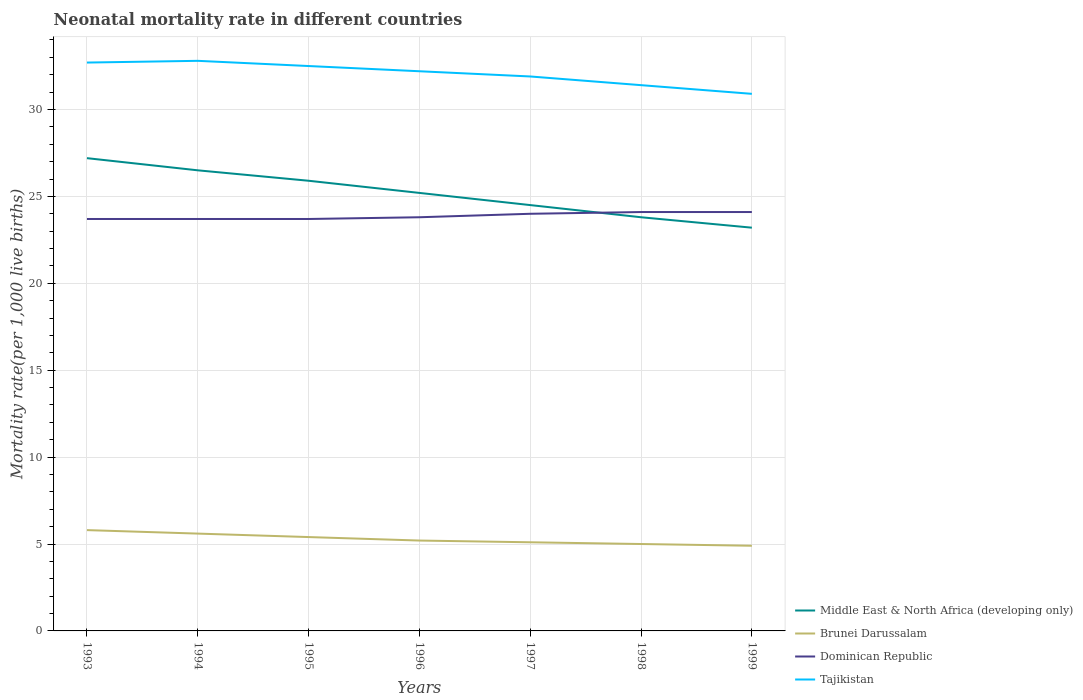Does the line corresponding to Brunei Darussalam intersect with the line corresponding to Dominican Republic?
Provide a succinct answer. No. Is the number of lines equal to the number of legend labels?
Make the answer very short. Yes. Across all years, what is the maximum neonatal mortality rate in Brunei Darussalam?
Offer a terse response. 4.9. In which year was the neonatal mortality rate in Middle East & North Africa (developing only) maximum?
Provide a succinct answer. 1999. What is the total neonatal mortality rate in Brunei Darussalam in the graph?
Offer a very short reply. 0.8. What is the difference between two consecutive major ticks on the Y-axis?
Provide a short and direct response. 5. Are the values on the major ticks of Y-axis written in scientific E-notation?
Offer a very short reply. No. Does the graph contain any zero values?
Give a very brief answer. No. Does the graph contain grids?
Your response must be concise. Yes. How many legend labels are there?
Your answer should be compact. 4. How are the legend labels stacked?
Offer a terse response. Vertical. What is the title of the graph?
Provide a succinct answer. Neonatal mortality rate in different countries. What is the label or title of the X-axis?
Give a very brief answer. Years. What is the label or title of the Y-axis?
Provide a short and direct response. Mortality rate(per 1,0 live births). What is the Mortality rate(per 1,000 live births) of Middle East & North Africa (developing only) in 1993?
Provide a succinct answer. 27.2. What is the Mortality rate(per 1,000 live births) of Dominican Republic in 1993?
Provide a succinct answer. 23.7. What is the Mortality rate(per 1,000 live births) of Tajikistan in 1993?
Give a very brief answer. 32.7. What is the Mortality rate(per 1,000 live births) in Dominican Republic in 1994?
Provide a succinct answer. 23.7. What is the Mortality rate(per 1,000 live births) in Tajikistan in 1994?
Your answer should be very brief. 32.8. What is the Mortality rate(per 1,000 live births) of Middle East & North Africa (developing only) in 1995?
Provide a succinct answer. 25.9. What is the Mortality rate(per 1,000 live births) in Brunei Darussalam in 1995?
Your answer should be very brief. 5.4. What is the Mortality rate(per 1,000 live births) of Dominican Republic in 1995?
Your answer should be compact. 23.7. What is the Mortality rate(per 1,000 live births) in Tajikistan in 1995?
Give a very brief answer. 32.5. What is the Mortality rate(per 1,000 live births) in Middle East & North Africa (developing only) in 1996?
Provide a succinct answer. 25.2. What is the Mortality rate(per 1,000 live births) in Dominican Republic in 1996?
Your answer should be very brief. 23.8. What is the Mortality rate(per 1,000 live births) of Tajikistan in 1996?
Your answer should be very brief. 32.2. What is the Mortality rate(per 1,000 live births) in Middle East & North Africa (developing only) in 1997?
Offer a very short reply. 24.5. What is the Mortality rate(per 1,000 live births) in Brunei Darussalam in 1997?
Give a very brief answer. 5.1. What is the Mortality rate(per 1,000 live births) of Dominican Republic in 1997?
Ensure brevity in your answer.  24. What is the Mortality rate(per 1,000 live births) in Tajikistan in 1997?
Keep it short and to the point. 31.9. What is the Mortality rate(per 1,000 live births) of Middle East & North Africa (developing only) in 1998?
Give a very brief answer. 23.8. What is the Mortality rate(per 1,000 live births) in Dominican Republic in 1998?
Offer a terse response. 24.1. What is the Mortality rate(per 1,000 live births) of Tajikistan in 1998?
Make the answer very short. 31.4. What is the Mortality rate(per 1,000 live births) of Middle East & North Africa (developing only) in 1999?
Give a very brief answer. 23.2. What is the Mortality rate(per 1,000 live births) of Dominican Republic in 1999?
Your answer should be compact. 24.1. What is the Mortality rate(per 1,000 live births) of Tajikistan in 1999?
Make the answer very short. 30.9. Across all years, what is the maximum Mortality rate(per 1,000 live births) of Middle East & North Africa (developing only)?
Keep it short and to the point. 27.2. Across all years, what is the maximum Mortality rate(per 1,000 live births) of Brunei Darussalam?
Give a very brief answer. 5.8. Across all years, what is the maximum Mortality rate(per 1,000 live births) in Dominican Republic?
Offer a very short reply. 24.1. Across all years, what is the maximum Mortality rate(per 1,000 live births) of Tajikistan?
Ensure brevity in your answer.  32.8. Across all years, what is the minimum Mortality rate(per 1,000 live births) of Middle East & North Africa (developing only)?
Provide a succinct answer. 23.2. Across all years, what is the minimum Mortality rate(per 1,000 live births) in Brunei Darussalam?
Make the answer very short. 4.9. Across all years, what is the minimum Mortality rate(per 1,000 live births) in Dominican Republic?
Your response must be concise. 23.7. Across all years, what is the minimum Mortality rate(per 1,000 live births) of Tajikistan?
Offer a terse response. 30.9. What is the total Mortality rate(per 1,000 live births) in Middle East & North Africa (developing only) in the graph?
Provide a succinct answer. 176.3. What is the total Mortality rate(per 1,000 live births) of Dominican Republic in the graph?
Your answer should be compact. 167.1. What is the total Mortality rate(per 1,000 live births) of Tajikistan in the graph?
Offer a terse response. 224.4. What is the difference between the Mortality rate(per 1,000 live births) of Dominican Republic in 1993 and that in 1994?
Your response must be concise. 0. What is the difference between the Mortality rate(per 1,000 live births) in Middle East & North Africa (developing only) in 1993 and that in 1996?
Your answer should be very brief. 2. What is the difference between the Mortality rate(per 1,000 live births) in Brunei Darussalam in 1993 and that in 1996?
Your response must be concise. 0.6. What is the difference between the Mortality rate(per 1,000 live births) in Dominican Republic in 1993 and that in 1996?
Provide a succinct answer. -0.1. What is the difference between the Mortality rate(per 1,000 live births) in Tajikistan in 1993 and that in 1997?
Make the answer very short. 0.8. What is the difference between the Mortality rate(per 1,000 live births) in Brunei Darussalam in 1993 and that in 1998?
Keep it short and to the point. 0.8. What is the difference between the Mortality rate(per 1,000 live births) of Tajikistan in 1993 and that in 1998?
Your response must be concise. 1.3. What is the difference between the Mortality rate(per 1,000 live births) in Middle East & North Africa (developing only) in 1993 and that in 1999?
Provide a succinct answer. 4. What is the difference between the Mortality rate(per 1,000 live births) of Dominican Republic in 1993 and that in 1999?
Your response must be concise. -0.4. What is the difference between the Mortality rate(per 1,000 live births) in Tajikistan in 1994 and that in 1995?
Make the answer very short. 0.3. What is the difference between the Mortality rate(per 1,000 live births) of Dominican Republic in 1994 and that in 1996?
Make the answer very short. -0.1. What is the difference between the Mortality rate(per 1,000 live births) in Brunei Darussalam in 1994 and that in 1997?
Your answer should be compact. 0.5. What is the difference between the Mortality rate(per 1,000 live births) in Middle East & North Africa (developing only) in 1994 and that in 1999?
Your answer should be very brief. 3.3. What is the difference between the Mortality rate(per 1,000 live births) in Tajikistan in 1994 and that in 1999?
Ensure brevity in your answer.  1.9. What is the difference between the Mortality rate(per 1,000 live births) in Brunei Darussalam in 1995 and that in 1996?
Provide a succinct answer. 0.2. What is the difference between the Mortality rate(per 1,000 live births) in Middle East & North Africa (developing only) in 1995 and that in 1997?
Offer a terse response. 1.4. What is the difference between the Mortality rate(per 1,000 live births) of Middle East & North Africa (developing only) in 1995 and that in 1998?
Offer a terse response. 2.1. What is the difference between the Mortality rate(per 1,000 live births) of Dominican Republic in 1995 and that in 1998?
Ensure brevity in your answer.  -0.4. What is the difference between the Mortality rate(per 1,000 live births) in Tajikistan in 1995 and that in 1998?
Your response must be concise. 1.1. What is the difference between the Mortality rate(per 1,000 live births) in Middle East & North Africa (developing only) in 1995 and that in 1999?
Your response must be concise. 2.7. What is the difference between the Mortality rate(per 1,000 live births) of Brunei Darussalam in 1995 and that in 1999?
Offer a very short reply. 0.5. What is the difference between the Mortality rate(per 1,000 live births) in Tajikistan in 1995 and that in 1999?
Provide a succinct answer. 1.6. What is the difference between the Mortality rate(per 1,000 live births) of Middle East & North Africa (developing only) in 1996 and that in 1997?
Keep it short and to the point. 0.7. What is the difference between the Mortality rate(per 1,000 live births) of Tajikistan in 1996 and that in 1997?
Make the answer very short. 0.3. What is the difference between the Mortality rate(per 1,000 live births) of Brunei Darussalam in 1996 and that in 1998?
Your response must be concise. 0.2. What is the difference between the Mortality rate(per 1,000 live births) of Middle East & North Africa (developing only) in 1996 and that in 1999?
Provide a succinct answer. 2. What is the difference between the Mortality rate(per 1,000 live births) of Tajikistan in 1996 and that in 1999?
Make the answer very short. 1.3. What is the difference between the Mortality rate(per 1,000 live births) in Middle East & North Africa (developing only) in 1997 and that in 1998?
Give a very brief answer. 0.7. What is the difference between the Mortality rate(per 1,000 live births) in Brunei Darussalam in 1997 and that in 1998?
Provide a succinct answer. 0.1. What is the difference between the Mortality rate(per 1,000 live births) of Brunei Darussalam in 1997 and that in 1999?
Your response must be concise. 0.2. What is the difference between the Mortality rate(per 1,000 live births) of Tajikistan in 1997 and that in 1999?
Keep it short and to the point. 1. What is the difference between the Mortality rate(per 1,000 live births) of Middle East & North Africa (developing only) in 1998 and that in 1999?
Provide a succinct answer. 0.6. What is the difference between the Mortality rate(per 1,000 live births) in Dominican Republic in 1998 and that in 1999?
Provide a succinct answer. 0. What is the difference between the Mortality rate(per 1,000 live births) of Tajikistan in 1998 and that in 1999?
Ensure brevity in your answer.  0.5. What is the difference between the Mortality rate(per 1,000 live births) in Middle East & North Africa (developing only) in 1993 and the Mortality rate(per 1,000 live births) in Brunei Darussalam in 1994?
Your response must be concise. 21.6. What is the difference between the Mortality rate(per 1,000 live births) of Brunei Darussalam in 1993 and the Mortality rate(per 1,000 live births) of Dominican Republic in 1994?
Your answer should be compact. -17.9. What is the difference between the Mortality rate(per 1,000 live births) of Brunei Darussalam in 1993 and the Mortality rate(per 1,000 live births) of Tajikistan in 1994?
Make the answer very short. -27. What is the difference between the Mortality rate(per 1,000 live births) in Middle East & North Africa (developing only) in 1993 and the Mortality rate(per 1,000 live births) in Brunei Darussalam in 1995?
Make the answer very short. 21.8. What is the difference between the Mortality rate(per 1,000 live births) of Middle East & North Africa (developing only) in 1993 and the Mortality rate(per 1,000 live births) of Dominican Republic in 1995?
Provide a short and direct response. 3.5. What is the difference between the Mortality rate(per 1,000 live births) in Brunei Darussalam in 1993 and the Mortality rate(per 1,000 live births) in Dominican Republic in 1995?
Make the answer very short. -17.9. What is the difference between the Mortality rate(per 1,000 live births) of Brunei Darussalam in 1993 and the Mortality rate(per 1,000 live births) of Tajikistan in 1995?
Provide a succinct answer. -26.7. What is the difference between the Mortality rate(per 1,000 live births) of Dominican Republic in 1993 and the Mortality rate(per 1,000 live births) of Tajikistan in 1995?
Provide a short and direct response. -8.8. What is the difference between the Mortality rate(per 1,000 live births) in Middle East & North Africa (developing only) in 1993 and the Mortality rate(per 1,000 live births) in Brunei Darussalam in 1996?
Keep it short and to the point. 22. What is the difference between the Mortality rate(per 1,000 live births) of Middle East & North Africa (developing only) in 1993 and the Mortality rate(per 1,000 live births) of Tajikistan in 1996?
Provide a short and direct response. -5. What is the difference between the Mortality rate(per 1,000 live births) of Brunei Darussalam in 1993 and the Mortality rate(per 1,000 live births) of Dominican Republic in 1996?
Your answer should be very brief. -18. What is the difference between the Mortality rate(per 1,000 live births) of Brunei Darussalam in 1993 and the Mortality rate(per 1,000 live births) of Tajikistan in 1996?
Your response must be concise. -26.4. What is the difference between the Mortality rate(per 1,000 live births) of Middle East & North Africa (developing only) in 1993 and the Mortality rate(per 1,000 live births) of Brunei Darussalam in 1997?
Offer a terse response. 22.1. What is the difference between the Mortality rate(per 1,000 live births) in Middle East & North Africa (developing only) in 1993 and the Mortality rate(per 1,000 live births) in Tajikistan in 1997?
Your response must be concise. -4.7. What is the difference between the Mortality rate(per 1,000 live births) of Brunei Darussalam in 1993 and the Mortality rate(per 1,000 live births) of Dominican Republic in 1997?
Make the answer very short. -18.2. What is the difference between the Mortality rate(per 1,000 live births) in Brunei Darussalam in 1993 and the Mortality rate(per 1,000 live births) in Tajikistan in 1997?
Ensure brevity in your answer.  -26.1. What is the difference between the Mortality rate(per 1,000 live births) of Middle East & North Africa (developing only) in 1993 and the Mortality rate(per 1,000 live births) of Dominican Republic in 1998?
Your answer should be very brief. 3.1. What is the difference between the Mortality rate(per 1,000 live births) in Middle East & North Africa (developing only) in 1993 and the Mortality rate(per 1,000 live births) in Tajikistan in 1998?
Your response must be concise. -4.2. What is the difference between the Mortality rate(per 1,000 live births) in Brunei Darussalam in 1993 and the Mortality rate(per 1,000 live births) in Dominican Republic in 1998?
Your answer should be very brief. -18.3. What is the difference between the Mortality rate(per 1,000 live births) of Brunei Darussalam in 1993 and the Mortality rate(per 1,000 live births) of Tajikistan in 1998?
Make the answer very short. -25.6. What is the difference between the Mortality rate(per 1,000 live births) of Dominican Republic in 1993 and the Mortality rate(per 1,000 live births) of Tajikistan in 1998?
Your answer should be very brief. -7.7. What is the difference between the Mortality rate(per 1,000 live births) in Middle East & North Africa (developing only) in 1993 and the Mortality rate(per 1,000 live births) in Brunei Darussalam in 1999?
Offer a terse response. 22.3. What is the difference between the Mortality rate(per 1,000 live births) in Middle East & North Africa (developing only) in 1993 and the Mortality rate(per 1,000 live births) in Dominican Republic in 1999?
Your response must be concise. 3.1. What is the difference between the Mortality rate(per 1,000 live births) of Middle East & North Africa (developing only) in 1993 and the Mortality rate(per 1,000 live births) of Tajikistan in 1999?
Give a very brief answer. -3.7. What is the difference between the Mortality rate(per 1,000 live births) in Brunei Darussalam in 1993 and the Mortality rate(per 1,000 live births) in Dominican Republic in 1999?
Provide a succinct answer. -18.3. What is the difference between the Mortality rate(per 1,000 live births) in Brunei Darussalam in 1993 and the Mortality rate(per 1,000 live births) in Tajikistan in 1999?
Your answer should be compact. -25.1. What is the difference between the Mortality rate(per 1,000 live births) of Dominican Republic in 1993 and the Mortality rate(per 1,000 live births) of Tajikistan in 1999?
Offer a terse response. -7.2. What is the difference between the Mortality rate(per 1,000 live births) in Middle East & North Africa (developing only) in 1994 and the Mortality rate(per 1,000 live births) in Brunei Darussalam in 1995?
Offer a very short reply. 21.1. What is the difference between the Mortality rate(per 1,000 live births) in Middle East & North Africa (developing only) in 1994 and the Mortality rate(per 1,000 live births) in Tajikistan in 1995?
Give a very brief answer. -6. What is the difference between the Mortality rate(per 1,000 live births) of Brunei Darussalam in 1994 and the Mortality rate(per 1,000 live births) of Dominican Republic in 1995?
Make the answer very short. -18.1. What is the difference between the Mortality rate(per 1,000 live births) in Brunei Darussalam in 1994 and the Mortality rate(per 1,000 live births) in Tajikistan in 1995?
Your response must be concise. -26.9. What is the difference between the Mortality rate(per 1,000 live births) of Middle East & North Africa (developing only) in 1994 and the Mortality rate(per 1,000 live births) of Brunei Darussalam in 1996?
Provide a short and direct response. 21.3. What is the difference between the Mortality rate(per 1,000 live births) of Middle East & North Africa (developing only) in 1994 and the Mortality rate(per 1,000 live births) of Dominican Republic in 1996?
Provide a short and direct response. 2.7. What is the difference between the Mortality rate(per 1,000 live births) of Middle East & North Africa (developing only) in 1994 and the Mortality rate(per 1,000 live births) of Tajikistan in 1996?
Offer a terse response. -5.7. What is the difference between the Mortality rate(per 1,000 live births) in Brunei Darussalam in 1994 and the Mortality rate(per 1,000 live births) in Dominican Republic in 1996?
Provide a succinct answer. -18.2. What is the difference between the Mortality rate(per 1,000 live births) in Brunei Darussalam in 1994 and the Mortality rate(per 1,000 live births) in Tajikistan in 1996?
Give a very brief answer. -26.6. What is the difference between the Mortality rate(per 1,000 live births) in Middle East & North Africa (developing only) in 1994 and the Mortality rate(per 1,000 live births) in Brunei Darussalam in 1997?
Give a very brief answer. 21.4. What is the difference between the Mortality rate(per 1,000 live births) of Middle East & North Africa (developing only) in 1994 and the Mortality rate(per 1,000 live births) of Tajikistan in 1997?
Your response must be concise. -5.4. What is the difference between the Mortality rate(per 1,000 live births) in Brunei Darussalam in 1994 and the Mortality rate(per 1,000 live births) in Dominican Republic in 1997?
Your response must be concise. -18.4. What is the difference between the Mortality rate(per 1,000 live births) in Brunei Darussalam in 1994 and the Mortality rate(per 1,000 live births) in Tajikistan in 1997?
Your answer should be very brief. -26.3. What is the difference between the Mortality rate(per 1,000 live births) of Dominican Republic in 1994 and the Mortality rate(per 1,000 live births) of Tajikistan in 1997?
Make the answer very short. -8.2. What is the difference between the Mortality rate(per 1,000 live births) in Middle East & North Africa (developing only) in 1994 and the Mortality rate(per 1,000 live births) in Dominican Republic in 1998?
Your answer should be compact. 2.4. What is the difference between the Mortality rate(per 1,000 live births) of Middle East & North Africa (developing only) in 1994 and the Mortality rate(per 1,000 live births) of Tajikistan in 1998?
Your answer should be compact. -4.9. What is the difference between the Mortality rate(per 1,000 live births) in Brunei Darussalam in 1994 and the Mortality rate(per 1,000 live births) in Dominican Republic in 1998?
Your answer should be compact. -18.5. What is the difference between the Mortality rate(per 1,000 live births) in Brunei Darussalam in 1994 and the Mortality rate(per 1,000 live births) in Tajikistan in 1998?
Your answer should be compact. -25.8. What is the difference between the Mortality rate(per 1,000 live births) of Dominican Republic in 1994 and the Mortality rate(per 1,000 live births) of Tajikistan in 1998?
Keep it short and to the point. -7.7. What is the difference between the Mortality rate(per 1,000 live births) in Middle East & North Africa (developing only) in 1994 and the Mortality rate(per 1,000 live births) in Brunei Darussalam in 1999?
Provide a succinct answer. 21.6. What is the difference between the Mortality rate(per 1,000 live births) in Middle East & North Africa (developing only) in 1994 and the Mortality rate(per 1,000 live births) in Dominican Republic in 1999?
Give a very brief answer. 2.4. What is the difference between the Mortality rate(per 1,000 live births) of Middle East & North Africa (developing only) in 1994 and the Mortality rate(per 1,000 live births) of Tajikistan in 1999?
Your answer should be very brief. -4.4. What is the difference between the Mortality rate(per 1,000 live births) in Brunei Darussalam in 1994 and the Mortality rate(per 1,000 live births) in Dominican Republic in 1999?
Offer a very short reply. -18.5. What is the difference between the Mortality rate(per 1,000 live births) in Brunei Darussalam in 1994 and the Mortality rate(per 1,000 live births) in Tajikistan in 1999?
Make the answer very short. -25.3. What is the difference between the Mortality rate(per 1,000 live births) of Middle East & North Africa (developing only) in 1995 and the Mortality rate(per 1,000 live births) of Brunei Darussalam in 1996?
Give a very brief answer. 20.7. What is the difference between the Mortality rate(per 1,000 live births) in Middle East & North Africa (developing only) in 1995 and the Mortality rate(per 1,000 live births) in Dominican Republic in 1996?
Offer a terse response. 2.1. What is the difference between the Mortality rate(per 1,000 live births) of Brunei Darussalam in 1995 and the Mortality rate(per 1,000 live births) of Dominican Republic in 1996?
Offer a terse response. -18.4. What is the difference between the Mortality rate(per 1,000 live births) in Brunei Darussalam in 1995 and the Mortality rate(per 1,000 live births) in Tajikistan in 1996?
Your answer should be compact. -26.8. What is the difference between the Mortality rate(per 1,000 live births) of Dominican Republic in 1995 and the Mortality rate(per 1,000 live births) of Tajikistan in 1996?
Make the answer very short. -8.5. What is the difference between the Mortality rate(per 1,000 live births) in Middle East & North Africa (developing only) in 1995 and the Mortality rate(per 1,000 live births) in Brunei Darussalam in 1997?
Provide a short and direct response. 20.8. What is the difference between the Mortality rate(per 1,000 live births) of Brunei Darussalam in 1995 and the Mortality rate(per 1,000 live births) of Dominican Republic in 1997?
Offer a very short reply. -18.6. What is the difference between the Mortality rate(per 1,000 live births) of Brunei Darussalam in 1995 and the Mortality rate(per 1,000 live births) of Tajikistan in 1997?
Give a very brief answer. -26.5. What is the difference between the Mortality rate(per 1,000 live births) of Dominican Republic in 1995 and the Mortality rate(per 1,000 live births) of Tajikistan in 1997?
Offer a very short reply. -8.2. What is the difference between the Mortality rate(per 1,000 live births) of Middle East & North Africa (developing only) in 1995 and the Mortality rate(per 1,000 live births) of Brunei Darussalam in 1998?
Make the answer very short. 20.9. What is the difference between the Mortality rate(per 1,000 live births) in Brunei Darussalam in 1995 and the Mortality rate(per 1,000 live births) in Dominican Republic in 1998?
Make the answer very short. -18.7. What is the difference between the Mortality rate(per 1,000 live births) in Brunei Darussalam in 1995 and the Mortality rate(per 1,000 live births) in Tajikistan in 1998?
Your answer should be very brief. -26. What is the difference between the Mortality rate(per 1,000 live births) in Middle East & North Africa (developing only) in 1995 and the Mortality rate(per 1,000 live births) in Dominican Republic in 1999?
Your response must be concise. 1.8. What is the difference between the Mortality rate(per 1,000 live births) in Brunei Darussalam in 1995 and the Mortality rate(per 1,000 live births) in Dominican Republic in 1999?
Your response must be concise. -18.7. What is the difference between the Mortality rate(per 1,000 live births) of Brunei Darussalam in 1995 and the Mortality rate(per 1,000 live births) of Tajikistan in 1999?
Offer a very short reply. -25.5. What is the difference between the Mortality rate(per 1,000 live births) of Dominican Republic in 1995 and the Mortality rate(per 1,000 live births) of Tajikistan in 1999?
Keep it short and to the point. -7.2. What is the difference between the Mortality rate(per 1,000 live births) of Middle East & North Africa (developing only) in 1996 and the Mortality rate(per 1,000 live births) of Brunei Darussalam in 1997?
Ensure brevity in your answer.  20.1. What is the difference between the Mortality rate(per 1,000 live births) in Brunei Darussalam in 1996 and the Mortality rate(per 1,000 live births) in Dominican Republic in 1997?
Offer a terse response. -18.8. What is the difference between the Mortality rate(per 1,000 live births) of Brunei Darussalam in 1996 and the Mortality rate(per 1,000 live births) of Tajikistan in 1997?
Offer a very short reply. -26.7. What is the difference between the Mortality rate(per 1,000 live births) in Middle East & North Africa (developing only) in 1996 and the Mortality rate(per 1,000 live births) in Brunei Darussalam in 1998?
Ensure brevity in your answer.  20.2. What is the difference between the Mortality rate(per 1,000 live births) in Middle East & North Africa (developing only) in 1996 and the Mortality rate(per 1,000 live births) in Tajikistan in 1998?
Your response must be concise. -6.2. What is the difference between the Mortality rate(per 1,000 live births) in Brunei Darussalam in 1996 and the Mortality rate(per 1,000 live births) in Dominican Republic in 1998?
Provide a succinct answer. -18.9. What is the difference between the Mortality rate(per 1,000 live births) of Brunei Darussalam in 1996 and the Mortality rate(per 1,000 live births) of Tajikistan in 1998?
Your answer should be compact. -26.2. What is the difference between the Mortality rate(per 1,000 live births) in Dominican Republic in 1996 and the Mortality rate(per 1,000 live births) in Tajikistan in 1998?
Your answer should be compact. -7.6. What is the difference between the Mortality rate(per 1,000 live births) of Middle East & North Africa (developing only) in 1996 and the Mortality rate(per 1,000 live births) of Brunei Darussalam in 1999?
Offer a terse response. 20.3. What is the difference between the Mortality rate(per 1,000 live births) in Middle East & North Africa (developing only) in 1996 and the Mortality rate(per 1,000 live births) in Dominican Republic in 1999?
Your answer should be very brief. 1.1. What is the difference between the Mortality rate(per 1,000 live births) in Middle East & North Africa (developing only) in 1996 and the Mortality rate(per 1,000 live births) in Tajikistan in 1999?
Offer a very short reply. -5.7. What is the difference between the Mortality rate(per 1,000 live births) of Brunei Darussalam in 1996 and the Mortality rate(per 1,000 live births) of Dominican Republic in 1999?
Offer a terse response. -18.9. What is the difference between the Mortality rate(per 1,000 live births) in Brunei Darussalam in 1996 and the Mortality rate(per 1,000 live births) in Tajikistan in 1999?
Make the answer very short. -25.7. What is the difference between the Mortality rate(per 1,000 live births) of Middle East & North Africa (developing only) in 1997 and the Mortality rate(per 1,000 live births) of Brunei Darussalam in 1998?
Offer a very short reply. 19.5. What is the difference between the Mortality rate(per 1,000 live births) of Brunei Darussalam in 1997 and the Mortality rate(per 1,000 live births) of Dominican Republic in 1998?
Your response must be concise. -19. What is the difference between the Mortality rate(per 1,000 live births) of Brunei Darussalam in 1997 and the Mortality rate(per 1,000 live births) of Tajikistan in 1998?
Your answer should be compact. -26.3. What is the difference between the Mortality rate(per 1,000 live births) in Middle East & North Africa (developing only) in 1997 and the Mortality rate(per 1,000 live births) in Brunei Darussalam in 1999?
Give a very brief answer. 19.6. What is the difference between the Mortality rate(per 1,000 live births) in Middle East & North Africa (developing only) in 1997 and the Mortality rate(per 1,000 live births) in Dominican Republic in 1999?
Offer a very short reply. 0.4. What is the difference between the Mortality rate(per 1,000 live births) of Brunei Darussalam in 1997 and the Mortality rate(per 1,000 live births) of Dominican Republic in 1999?
Ensure brevity in your answer.  -19. What is the difference between the Mortality rate(per 1,000 live births) in Brunei Darussalam in 1997 and the Mortality rate(per 1,000 live births) in Tajikistan in 1999?
Give a very brief answer. -25.8. What is the difference between the Mortality rate(per 1,000 live births) in Middle East & North Africa (developing only) in 1998 and the Mortality rate(per 1,000 live births) in Dominican Republic in 1999?
Ensure brevity in your answer.  -0.3. What is the difference between the Mortality rate(per 1,000 live births) of Middle East & North Africa (developing only) in 1998 and the Mortality rate(per 1,000 live births) of Tajikistan in 1999?
Provide a succinct answer. -7.1. What is the difference between the Mortality rate(per 1,000 live births) in Brunei Darussalam in 1998 and the Mortality rate(per 1,000 live births) in Dominican Republic in 1999?
Your response must be concise. -19.1. What is the difference between the Mortality rate(per 1,000 live births) of Brunei Darussalam in 1998 and the Mortality rate(per 1,000 live births) of Tajikistan in 1999?
Ensure brevity in your answer.  -25.9. What is the average Mortality rate(per 1,000 live births) of Middle East & North Africa (developing only) per year?
Offer a very short reply. 25.19. What is the average Mortality rate(per 1,000 live births) of Brunei Darussalam per year?
Provide a succinct answer. 5.29. What is the average Mortality rate(per 1,000 live births) in Dominican Republic per year?
Give a very brief answer. 23.87. What is the average Mortality rate(per 1,000 live births) of Tajikistan per year?
Ensure brevity in your answer.  32.06. In the year 1993, what is the difference between the Mortality rate(per 1,000 live births) of Middle East & North Africa (developing only) and Mortality rate(per 1,000 live births) of Brunei Darussalam?
Your answer should be compact. 21.4. In the year 1993, what is the difference between the Mortality rate(per 1,000 live births) in Middle East & North Africa (developing only) and Mortality rate(per 1,000 live births) in Dominican Republic?
Your answer should be very brief. 3.5. In the year 1993, what is the difference between the Mortality rate(per 1,000 live births) of Middle East & North Africa (developing only) and Mortality rate(per 1,000 live births) of Tajikistan?
Your answer should be compact. -5.5. In the year 1993, what is the difference between the Mortality rate(per 1,000 live births) of Brunei Darussalam and Mortality rate(per 1,000 live births) of Dominican Republic?
Your answer should be very brief. -17.9. In the year 1993, what is the difference between the Mortality rate(per 1,000 live births) of Brunei Darussalam and Mortality rate(per 1,000 live births) of Tajikistan?
Provide a succinct answer. -26.9. In the year 1993, what is the difference between the Mortality rate(per 1,000 live births) of Dominican Republic and Mortality rate(per 1,000 live births) of Tajikistan?
Make the answer very short. -9. In the year 1994, what is the difference between the Mortality rate(per 1,000 live births) in Middle East & North Africa (developing only) and Mortality rate(per 1,000 live births) in Brunei Darussalam?
Give a very brief answer. 20.9. In the year 1994, what is the difference between the Mortality rate(per 1,000 live births) of Middle East & North Africa (developing only) and Mortality rate(per 1,000 live births) of Dominican Republic?
Keep it short and to the point. 2.8. In the year 1994, what is the difference between the Mortality rate(per 1,000 live births) of Middle East & North Africa (developing only) and Mortality rate(per 1,000 live births) of Tajikistan?
Provide a succinct answer. -6.3. In the year 1994, what is the difference between the Mortality rate(per 1,000 live births) in Brunei Darussalam and Mortality rate(per 1,000 live births) in Dominican Republic?
Give a very brief answer. -18.1. In the year 1994, what is the difference between the Mortality rate(per 1,000 live births) in Brunei Darussalam and Mortality rate(per 1,000 live births) in Tajikistan?
Your response must be concise. -27.2. In the year 1994, what is the difference between the Mortality rate(per 1,000 live births) in Dominican Republic and Mortality rate(per 1,000 live births) in Tajikistan?
Your answer should be compact. -9.1. In the year 1995, what is the difference between the Mortality rate(per 1,000 live births) in Middle East & North Africa (developing only) and Mortality rate(per 1,000 live births) in Dominican Republic?
Ensure brevity in your answer.  2.2. In the year 1995, what is the difference between the Mortality rate(per 1,000 live births) in Brunei Darussalam and Mortality rate(per 1,000 live births) in Dominican Republic?
Ensure brevity in your answer.  -18.3. In the year 1995, what is the difference between the Mortality rate(per 1,000 live births) in Brunei Darussalam and Mortality rate(per 1,000 live births) in Tajikistan?
Offer a very short reply. -27.1. In the year 1995, what is the difference between the Mortality rate(per 1,000 live births) in Dominican Republic and Mortality rate(per 1,000 live births) in Tajikistan?
Your answer should be very brief. -8.8. In the year 1996, what is the difference between the Mortality rate(per 1,000 live births) of Middle East & North Africa (developing only) and Mortality rate(per 1,000 live births) of Tajikistan?
Your response must be concise. -7. In the year 1996, what is the difference between the Mortality rate(per 1,000 live births) of Brunei Darussalam and Mortality rate(per 1,000 live births) of Dominican Republic?
Ensure brevity in your answer.  -18.6. In the year 1996, what is the difference between the Mortality rate(per 1,000 live births) of Brunei Darussalam and Mortality rate(per 1,000 live births) of Tajikistan?
Keep it short and to the point. -27. In the year 1996, what is the difference between the Mortality rate(per 1,000 live births) in Dominican Republic and Mortality rate(per 1,000 live births) in Tajikistan?
Offer a terse response. -8.4. In the year 1997, what is the difference between the Mortality rate(per 1,000 live births) of Middle East & North Africa (developing only) and Mortality rate(per 1,000 live births) of Dominican Republic?
Your answer should be very brief. 0.5. In the year 1997, what is the difference between the Mortality rate(per 1,000 live births) in Brunei Darussalam and Mortality rate(per 1,000 live births) in Dominican Republic?
Ensure brevity in your answer.  -18.9. In the year 1997, what is the difference between the Mortality rate(per 1,000 live births) in Brunei Darussalam and Mortality rate(per 1,000 live births) in Tajikistan?
Keep it short and to the point. -26.8. In the year 1997, what is the difference between the Mortality rate(per 1,000 live births) of Dominican Republic and Mortality rate(per 1,000 live births) of Tajikistan?
Provide a short and direct response. -7.9. In the year 1998, what is the difference between the Mortality rate(per 1,000 live births) of Middle East & North Africa (developing only) and Mortality rate(per 1,000 live births) of Brunei Darussalam?
Your answer should be very brief. 18.8. In the year 1998, what is the difference between the Mortality rate(per 1,000 live births) of Middle East & North Africa (developing only) and Mortality rate(per 1,000 live births) of Tajikistan?
Give a very brief answer. -7.6. In the year 1998, what is the difference between the Mortality rate(per 1,000 live births) in Brunei Darussalam and Mortality rate(per 1,000 live births) in Dominican Republic?
Provide a succinct answer. -19.1. In the year 1998, what is the difference between the Mortality rate(per 1,000 live births) in Brunei Darussalam and Mortality rate(per 1,000 live births) in Tajikistan?
Keep it short and to the point. -26.4. In the year 1998, what is the difference between the Mortality rate(per 1,000 live births) in Dominican Republic and Mortality rate(per 1,000 live births) in Tajikistan?
Offer a terse response. -7.3. In the year 1999, what is the difference between the Mortality rate(per 1,000 live births) of Brunei Darussalam and Mortality rate(per 1,000 live births) of Dominican Republic?
Provide a succinct answer. -19.2. In the year 1999, what is the difference between the Mortality rate(per 1,000 live births) of Brunei Darussalam and Mortality rate(per 1,000 live births) of Tajikistan?
Make the answer very short. -26. In the year 1999, what is the difference between the Mortality rate(per 1,000 live births) in Dominican Republic and Mortality rate(per 1,000 live births) in Tajikistan?
Give a very brief answer. -6.8. What is the ratio of the Mortality rate(per 1,000 live births) in Middle East & North Africa (developing only) in 1993 to that in 1994?
Keep it short and to the point. 1.03. What is the ratio of the Mortality rate(per 1,000 live births) of Brunei Darussalam in 1993 to that in 1994?
Your response must be concise. 1.04. What is the ratio of the Mortality rate(per 1,000 live births) in Tajikistan in 1993 to that in 1994?
Offer a very short reply. 1. What is the ratio of the Mortality rate(per 1,000 live births) of Middle East & North Africa (developing only) in 1993 to that in 1995?
Your answer should be compact. 1.05. What is the ratio of the Mortality rate(per 1,000 live births) of Brunei Darussalam in 1993 to that in 1995?
Your answer should be compact. 1.07. What is the ratio of the Mortality rate(per 1,000 live births) of Tajikistan in 1993 to that in 1995?
Your response must be concise. 1.01. What is the ratio of the Mortality rate(per 1,000 live births) of Middle East & North Africa (developing only) in 1993 to that in 1996?
Offer a very short reply. 1.08. What is the ratio of the Mortality rate(per 1,000 live births) of Brunei Darussalam in 1993 to that in 1996?
Your answer should be compact. 1.12. What is the ratio of the Mortality rate(per 1,000 live births) of Dominican Republic in 1993 to that in 1996?
Provide a succinct answer. 1. What is the ratio of the Mortality rate(per 1,000 live births) in Tajikistan in 1993 to that in 1996?
Your answer should be very brief. 1.02. What is the ratio of the Mortality rate(per 1,000 live births) of Middle East & North Africa (developing only) in 1993 to that in 1997?
Your answer should be compact. 1.11. What is the ratio of the Mortality rate(per 1,000 live births) of Brunei Darussalam in 1993 to that in 1997?
Offer a terse response. 1.14. What is the ratio of the Mortality rate(per 1,000 live births) of Dominican Republic in 1993 to that in 1997?
Keep it short and to the point. 0.99. What is the ratio of the Mortality rate(per 1,000 live births) of Tajikistan in 1993 to that in 1997?
Offer a terse response. 1.03. What is the ratio of the Mortality rate(per 1,000 live births) of Brunei Darussalam in 1993 to that in 1998?
Ensure brevity in your answer.  1.16. What is the ratio of the Mortality rate(per 1,000 live births) of Dominican Republic in 1993 to that in 1998?
Make the answer very short. 0.98. What is the ratio of the Mortality rate(per 1,000 live births) in Tajikistan in 1993 to that in 1998?
Ensure brevity in your answer.  1.04. What is the ratio of the Mortality rate(per 1,000 live births) of Middle East & North Africa (developing only) in 1993 to that in 1999?
Provide a succinct answer. 1.17. What is the ratio of the Mortality rate(per 1,000 live births) in Brunei Darussalam in 1993 to that in 1999?
Your response must be concise. 1.18. What is the ratio of the Mortality rate(per 1,000 live births) in Dominican Republic in 1993 to that in 1999?
Provide a short and direct response. 0.98. What is the ratio of the Mortality rate(per 1,000 live births) in Tajikistan in 1993 to that in 1999?
Your answer should be very brief. 1.06. What is the ratio of the Mortality rate(per 1,000 live births) in Middle East & North Africa (developing only) in 1994 to that in 1995?
Offer a very short reply. 1.02. What is the ratio of the Mortality rate(per 1,000 live births) in Brunei Darussalam in 1994 to that in 1995?
Make the answer very short. 1.04. What is the ratio of the Mortality rate(per 1,000 live births) of Dominican Republic in 1994 to that in 1995?
Offer a terse response. 1. What is the ratio of the Mortality rate(per 1,000 live births) of Tajikistan in 1994 to that in 1995?
Your answer should be compact. 1.01. What is the ratio of the Mortality rate(per 1,000 live births) in Middle East & North Africa (developing only) in 1994 to that in 1996?
Your answer should be very brief. 1.05. What is the ratio of the Mortality rate(per 1,000 live births) of Brunei Darussalam in 1994 to that in 1996?
Ensure brevity in your answer.  1.08. What is the ratio of the Mortality rate(per 1,000 live births) of Tajikistan in 1994 to that in 1996?
Offer a very short reply. 1.02. What is the ratio of the Mortality rate(per 1,000 live births) in Middle East & North Africa (developing only) in 1994 to that in 1997?
Make the answer very short. 1.08. What is the ratio of the Mortality rate(per 1,000 live births) in Brunei Darussalam in 1994 to that in 1997?
Your answer should be compact. 1.1. What is the ratio of the Mortality rate(per 1,000 live births) of Dominican Republic in 1994 to that in 1997?
Ensure brevity in your answer.  0.99. What is the ratio of the Mortality rate(per 1,000 live births) in Tajikistan in 1994 to that in 1997?
Provide a succinct answer. 1.03. What is the ratio of the Mortality rate(per 1,000 live births) in Middle East & North Africa (developing only) in 1994 to that in 1998?
Provide a short and direct response. 1.11. What is the ratio of the Mortality rate(per 1,000 live births) in Brunei Darussalam in 1994 to that in 1998?
Your answer should be compact. 1.12. What is the ratio of the Mortality rate(per 1,000 live births) of Dominican Republic in 1994 to that in 1998?
Ensure brevity in your answer.  0.98. What is the ratio of the Mortality rate(per 1,000 live births) of Tajikistan in 1994 to that in 1998?
Keep it short and to the point. 1.04. What is the ratio of the Mortality rate(per 1,000 live births) of Middle East & North Africa (developing only) in 1994 to that in 1999?
Your answer should be compact. 1.14. What is the ratio of the Mortality rate(per 1,000 live births) in Dominican Republic in 1994 to that in 1999?
Your answer should be compact. 0.98. What is the ratio of the Mortality rate(per 1,000 live births) of Tajikistan in 1994 to that in 1999?
Make the answer very short. 1.06. What is the ratio of the Mortality rate(per 1,000 live births) in Middle East & North Africa (developing only) in 1995 to that in 1996?
Your answer should be very brief. 1.03. What is the ratio of the Mortality rate(per 1,000 live births) in Dominican Republic in 1995 to that in 1996?
Offer a very short reply. 1. What is the ratio of the Mortality rate(per 1,000 live births) in Tajikistan in 1995 to that in 1996?
Give a very brief answer. 1.01. What is the ratio of the Mortality rate(per 1,000 live births) of Middle East & North Africa (developing only) in 1995 to that in 1997?
Your answer should be compact. 1.06. What is the ratio of the Mortality rate(per 1,000 live births) of Brunei Darussalam in 1995 to that in 1997?
Provide a short and direct response. 1.06. What is the ratio of the Mortality rate(per 1,000 live births) of Dominican Republic in 1995 to that in 1997?
Make the answer very short. 0.99. What is the ratio of the Mortality rate(per 1,000 live births) in Tajikistan in 1995 to that in 1997?
Your answer should be compact. 1.02. What is the ratio of the Mortality rate(per 1,000 live births) of Middle East & North Africa (developing only) in 1995 to that in 1998?
Provide a succinct answer. 1.09. What is the ratio of the Mortality rate(per 1,000 live births) in Dominican Republic in 1995 to that in 1998?
Your answer should be very brief. 0.98. What is the ratio of the Mortality rate(per 1,000 live births) of Tajikistan in 1995 to that in 1998?
Offer a terse response. 1.03. What is the ratio of the Mortality rate(per 1,000 live births) in Middle East & North Africa (developing only) in 1995 to that in 1999?
Your response must be concise. 1.12. What is the ratio of the Mortality rate(per 1,000 live births) of Brunei Darussalam in 1995 to that in 1999?
Provide a short and direct response. 1.1. What is the ratio of the Mortality rate(per 1,000 live births) in Dominican Republic in 1995 to that in 1999?
Offer a terse response. 0.98. What is the ratio of the Mortality rate(per 1,000 live births) of Tajikistan in 1995 to that in 1999?
Ensure brevity in your answer.  1.05. What is the ratio of the Mortality rate(per 1,000 live births) in Middle East & North Africa (developing only) in 1996 to that in 1997?
Provide a short and direct response. 1.03. What is the ratio of the Mortality rate(per 1,000 live births) of Brunei Darussalam in 1996 to that in 1997?
Ensure brevity in your answer.  1.02. What is the ratio of the Mortality rate(per 1,000 live births) of Dominican Republic in 1996 to that in 1997?
Make the answer very short. 0.99. What is the ratio of the Mortality rate(per 1,000 live births) of Tajikistan in 1996 to that in 1997?
Keep it short and to the point. 1.01. What is the ratio of the Mortality rate(per 1,000 live births) of Middle East & North Africa (developing only) in 1996 to that in 1998?
Offer a very short reply. 1.06. What is the ratio of the Mortality rate(per 1,000 live births) of Brunei Darussalam in 1996 to that in 1998?
Your answer should be compact. 1.04. What is the ratio of the Mortality rate(per 1,000 live births) of Dominican Republic in 1996 to that in 1998?
Ensure brevity in your answer.  0.99. What is the ratio of the Mortality rate(per 1,000 live births) of Tajikistan in 1996 to that in 1998?
Keep it short and to the point. 1.03. What is the ratio of the Mortality rate(per 1,000 live births) of Middle East & North Africa (developing only) in 1996 to that in 1999?
Make the answer very short. 1.09. What is the ratio of the Mortality rate(per 1,000 live births) of Brunei Darussalam in 1996 to that in 1999?
Your response must be concise. 1.06. What is the ratio of the Mortality rate(per 1,000 live births) of Dominican Republic in 1996 to that in 1999?
Your response must be concise. 0.99. What is the ratio of the Mortality rate(per 1,000 live births) in Tajikistan in 1996 to that in 1999?
Your response must be concise. 1.04. What is the ratio of the Mortality rate(per 1,000 live births) in Middle East & North Africa (developing only) in 1997 to that in 1998?
Provide a short and direct response. 1.03. What is the ratio of the Mortality rate(per 1,000 live births) of Dominican Republic in 1997 to that in 1998?
Keep it short and to the point. 1. What is the ratio of the Mortality rate(per 1,000 live births) of Tajikistan in 1997 to that in 1998?
Your answer should be compact. 1.02. What is the ratio of the Mortality rate(per 1,000 live births) of Middle East & North Africa (developing only) in 1997 to that in 1999?
Keep it short and to the point. 1.06. What is the ratio of the Mortality rate(per 1,000 live births) of Brunei Darussalam in 1997 to that in 1999?
Offer a terse response. 1.04. What is the ratio of the Mortality rate(per 1,000 live births) of Dominican Republic in 1997 to that in 1999?
Give a very brief answer. 1. What is the ratio of the Mortality rate(per 1,000 live births) of Tajikistan in 1997 to that in 1999?
Give a very brief answer. 1.03. What is the ratio of the Mortality rate(per 1,000 live births) of Middle East & North Africa (developing only) in 1998 to that in 1999?
Ensure brevity in your answer.  1.03. What is the ratio of the Mortality rate(per 1,000 live births) of Brunei Darussalam in 1998 to that in 1999?
Offer a terse response. 1.02. What is the ratio of the Mortality rate(per 1,000 live births) in Dominican Republic in 1998 to that in 1999?
Give a very brief answer. 1. What is the ratio of the Mortality rate(per 1,000 live births) of Tajikistan in 1998 to that in 1999?
Provide a short and direct response. 1.02. What is the difference between the highest and the second highest Mortality rate(per 1,000 live births) of Middle East & North Africa (developing only)?
Your answer should be very brief. 0.7. What is the difference between the highest and the second highest Mortality rate(per 1,000 live births) in Brunei Darussalam?
Offer a terse response. 0.2. What is the difference between the highest and the second highest Mortality rate(per 1,000 live births) in Dominican Republic?
Provide a short and direct response. 0. 